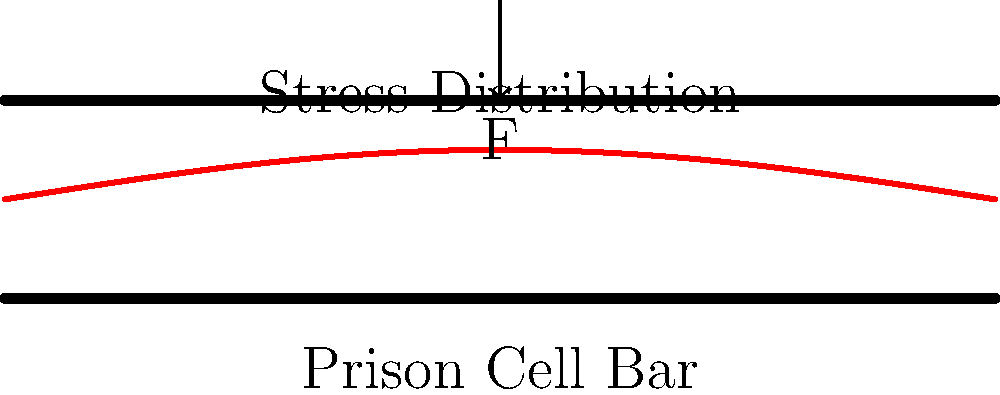In a prison cell, a horizontal bar is subjected to a vertical point load F at its center. Assuming the bar is fixed at both ends, which of the following best describes the stress distribution along the length of the bar?

A) Uniform stress distribution
B) Linear stress distribution
C) Sinusoidal stress distribution
D) Exponential stress distribution To analyze the stress distribution in a prison cell bar under a central point load, we need to consider the following steps:

1. Boundary conditions: The bar is fixed at both ends, which means it's a statically indeterminate problem.

2. Loading condition: A point load F is applied at the center of the bar.

3. Bending moment distribution: The bending moment will be maximum at the center and decrease towards the ends.

4. Stress-moment relationship: Stress is proportional to the bending moment in beam theory.

5. Shape of the deflection curve: For a centrally loaded beam with fixed ends, the deflection curve resembles a sinusoidal shape.

6. Stress distribution: Since stress is proportional to the bending moment, and the bending moment follows the shape of the deflection curve (but inverted), the stress distribution will also be sinusoidal.

The sinusoidal stress distribution reflects the complex interplay between the applied load, the beam's resistance to bending, and the fixed end conditions. This distribution ensures a smooth transition of stresses along the length of the bar, with maximum stress at the center where the load is applied and zero stress at the fixed ends.

For a crime biography enthusiast, this stress analysis might evoke thoughts about the psychological stress experienced by inmates in confined spaces, drawing parallels between physical and emotional strain in a prison environment.
Answer: C) Sinusoidal stress distribution 